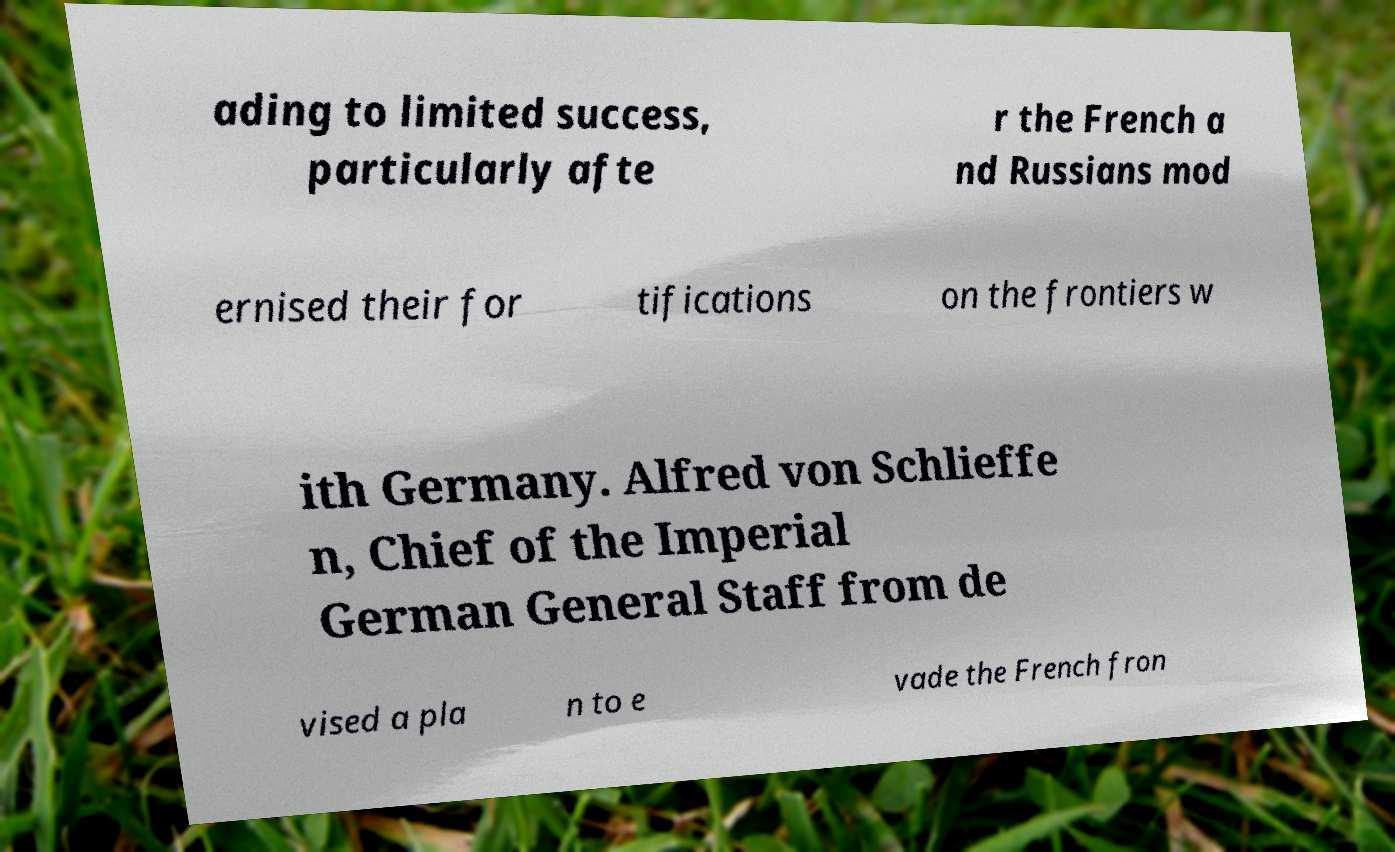Please read and relay the text visible in this image. What does it say? ading to limited success, particularly afte r the French a nd Russians mod ernised their for tifications on the frontiers w ith Germany. Alfred von Schlieffe n, Chief of the Imperial German General Staff from de vised a pla n to e vade the French fron 